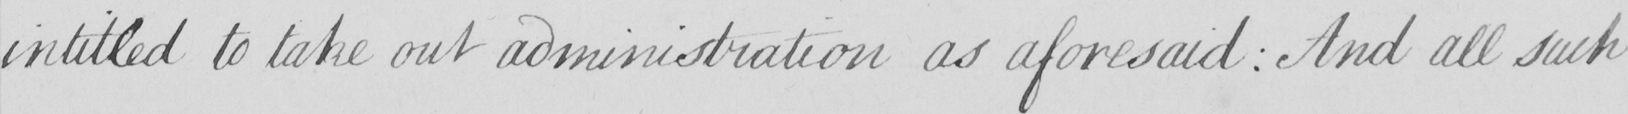Can you read and transcribe this handwriting? intitled to take out administration as aforesaid :  And all such 